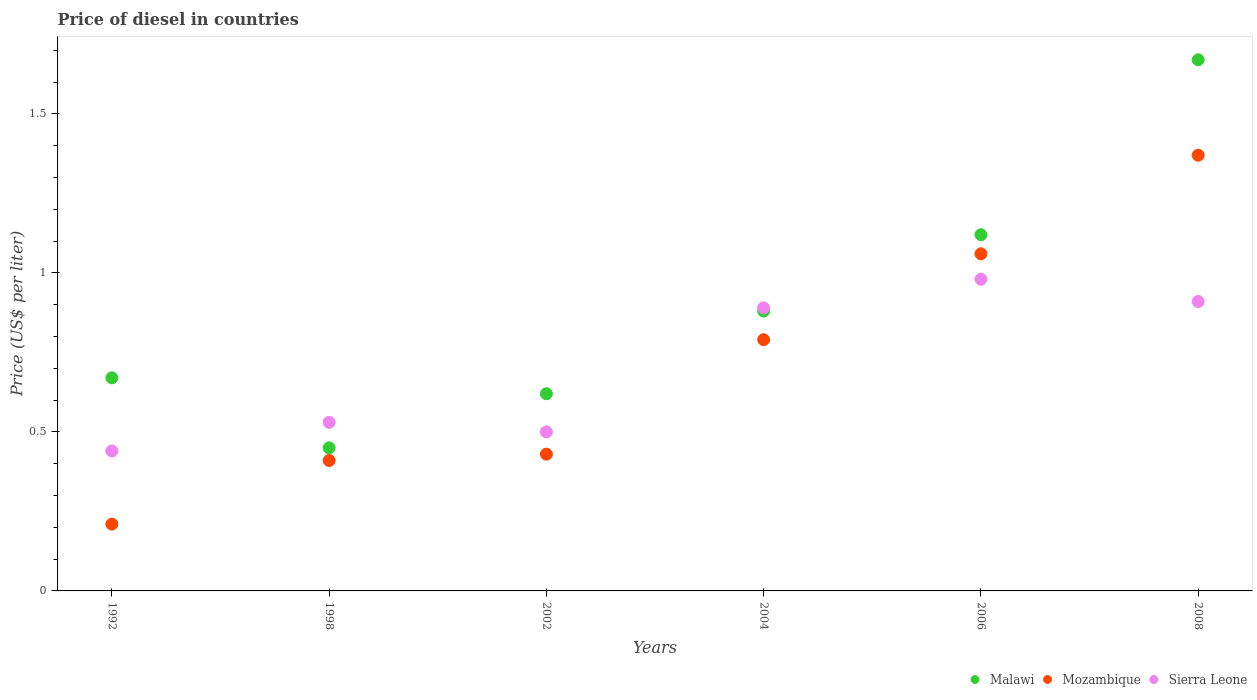How many different coloured dotlines are there?
Offer a very short reply. 3. What is the price of diesel in Mozambique in 2006?
Provide a short and direct response. 1.06. Across all years, what is the maximum price of diesel in Sierra Leone?
Give a very brief answer. 0.98. Across all years, what is the minimum price of diesel in Mozambique?
Give a very brief answer. 0.21. In which year was the price of diesel in Malawi maximum?
Offer a very short reply. 2008. In which year was the price of diesel in Malawi minimum?
Keep it short and to the point. 1998. What is the total price of diesel in Mozambique in the graph?
Your answer should be very brief. 4.27. What is the difference between the price of diesel in Sierra Leone in 1998 and that in 2008?
Provide a succinct answer. -0.38. What is the difference between the price of diesel in Mozambique in 2006 and the price of diesel in Sierra Leone in 1992?
Make the answer very short. 0.62. What is the average price of diesel in Sierra Leone per year?
Offer a terse response. 0.71. In the year 2008, what is the difference between the price of diesel in Mozambique and price of diesel in Sierra Leone?
Your answer should be very brief. 0.46. What is the ratio of the price of diesel in Malawi in 2004 to that in 2006?
Your answer should be very brief. 0.79. Is the difference between the price of diesel in Mozambique in 2006 and 2008 greater than the difference between the price of diesel in Sierra Leone in 2006 and 2008?
Provide a short and direct response. No. What is the difference between the highest and the second highest price of diesel in Sierra Leone?
Offer a very short reply. 0.07. What is the difference between the highest and the lowest price of diesel in Sierra Leone?
Provide a short and direct response. 0.54. Is the sum of the price of diesel in Mozambique in 1992 and 2004 greater than the maximum price of diesel in Malawi across all years?
Offer a terse response. No. Is it the case that in every year, the sum of the price of diesel in Sierra Leone and price of diesel in Mozambique  is greater than the price of diesel in Malawi?
Offer a terse response. No. Does the price of diesel in Malawi monotonically increase over the years?
Make the answer very short. No. Are the values on the major ticks of Y-axis written in scientific E-notation?
Provide a short and direct response. No. How many legend labels are there?
Ensure brevity in your answer.  3. How are the legend labels stacked?
Offer a terse response. Horizontal. What is the title of the graph?
Ensure brevity in your answer.  Price of diesel in countries. Does "European Union" appear as one of the legend labels in the graph?
Ensure brevity in your answer.  No. What is the label or title of the X-axis?
Give a very brief answer. Years. What is the label or title of the Y-axis?
Make the answer very short. Price (US$ per liter). What is the Price (US$ per liter) of Malawi in 1992?
Your response must be concise. 0.67. What is the Price (US$ per liter) in Mozambique in 1992?
Ensure brevity in your answer.  0.21. What is the Price (US$ per liter) of Sierra Leone in 1992?
Ensure brevity in your answer.  0.44. What is the Price (US$ per liter) in Malawi in 1998?
Give a very brief answer. 0.45. What is the Price (US$ per liter) in Mozambique in 1998?
Ensure brevity in your answer.  0.41. What is the Price (US$ per liter) of Sierra Leone in 1998?
Offer a terse response. 0.53. What is the Price (US$ per liter) of Malawi in 2002?
Your response must be concise. 0.62. What is the Price (US$ per liter) in Mozambique in 2002?
Your answer should be compact. 0.43. What is the Price (US$ per liter) in Sierra Leone in 2002?
Your response must be concise. 0.5. What is the Price (US$ per liter) of Malawi in 2004?
Your response must be concise. 0.88. What is the Price (US$ per liter) of Mozambique in 2004?
Ensure brevity in your answer.  0.79. What is the Price (US$ per liter) of Sierra Leone in 2004?
Give a very brief answer. 0.89. What is the Price (US$ per liter) in Malawi in 2006?
Offer a very short reply. 1.12. What is the Price (US$ per liter) in Mozambique in 2006?
Your answer should be compact. 1.06. What is the Price (US$ per liter) in Malawi in 2008?
Give a very brief answer. 1.67. What is the Price (US$ per liter) of Mozambique in 2008?
Give a very brief answer. 1.37. What is the Price (US$ per liter) in Sierra Leone in 2008?
Your answer should be very brief. 0.91. Across all years, what is the maximum Price (US$ per liter) in Malawi?
Ensure brevity in your answer.  1.67. Across all years, what is the maximum Price (US$ per liter) in Mozambique?
Offer a terse response. 1.37. Across all years, what is the maximum Price (US$ per liter) of Sierra Leone?
Your answer should be compact. 0.98. Across all years, what is the minimum Price (US$ per liter) in Malawi?
Offer a very short reply. 0.45. Across all years, what is the minimum Price (US$ per liter) in Mozambique?
Provide a short and direct response. 0.21. Across all years, what is the minimum Price (US$ per liter) of Sierra Leone?
Make the answer very short. 0.44. What is the total Price (US$ per liter) in Malawi in the graph?
Provide a succinct answer. 5.41. What is the total Price (US$ per liter) of Mozambique in the graph?
Provide a succinct answer. 4.27. What is the total Price (US$ per liter) in Sierra Leone in the graph?
Your answer should be compact. 4.25. What is the difference between the Price (US$ per liter) in Malawi in 1992 and that in 1998?
Your answer should be compact. 0.22. What is the difference between the Price (US$ per liter) in Sierra Leone in 1992 and that in 1998?
Provide a short and direct response. -0.09. What is the difference between the Price (US$ per liter) in Malawi in 1992 and that in 2002?
Give a very brief answer. 0.05. What is the difference between the Price (US$ per liter) in Mozambique in 1992 and that in 2002?
Provide a short and direct response. -0.22. What is the difference between the Price (US$ per liter) in Sierra Leone in 1992 and that in 2002?
Your answer should be very brief. -0.06. What is the difference between the Price (US$ per liter) in Malawi in 1992 and that in 2004?
Give a very brief answer. -0.21. What is the difference between the Price (US$ per liter) of Mozambique in 1992 and that in 2004?
Offer a very short reply. -0.58. What is the difference between the Price (US$ per liter) of Sierra Leone in 1992 and that in 2004?
Offer a terse response. -0.45. What is the difference between the Price (US$ per liter) of Malawi in 1992 and that in 2006?
Offer a terse response. -0.45. What is the difference between the Price (US$ per liter) of Mozambique in 1992 and that in 2006?
Give a very brief answer. -0.85. What is the difference between the Price (US$ per liter) in Sierra Leone in 1992 and that in 2006?
Your response must be concise. -0.54. What is the difference between the Price (US$ per liter) in Mozambique in 1992 and that in 2008?
Ensure brevity in your answer.  -1.16. What is the difference between the Price (US$ per liter) of Sierra Leone in 1992 and that in 2008?
Your answer should be very brief. -0.47. What is the difference between the Price (US$ per liter) of Malawi in 1998 and that in 2002?
Ensure brevity in your answer.  -0.17. What is the difference between the Price (US$ per liter) in Mozambique in 1998 and that in 2002?
Your answer should be very brief. -0.02. What is the difference between the Price (US$ per liter) in Malawi in 1998 and that in 2004?
Your response must be concise. -0.43. What is the difference between the Price (US$ per liter) in Mozambique in 1998 and that in 2004?
Make the answer very short. -0.38. What is the difference between the Price (US$ per liter) in Sierra Leone in 1998 and that in 2004?
Your response must be concise. -0.36. What is the difference between the Price (US$ per liter) of Malawi in 1998 and that in 2006?
Provide a succinct answer. -0.67. What is the difference between the Price (US$ per liter) of Mozambique in 1998 and that in 2006?
Ensure brevity in your answer.  -0.65. What is the difference between the Price (US$ per liter) of Sierra Leone in 1998 and that in 2006?
Provide a succinct answer. -0.45. What is the difference between the Price (US$ per liter) of Malawi in 1998 and that in 2008?
Offer a terse response. -1.22. What is the difference between the Price (US$ per liter) in Mozambique in 1998 and that in 2008?
Your answer should be very brief. -0.96. What is the difference between the Price (US$ per liter) in Sierra Leone in 1998 and that in 2008?
Provide a short and direct response. -0.38. What is the difference between the Price (US$ per liter) in Malawi in 2002 and that in 2004?
Your answer should be compact. -0.26. What is the difference between the Price (US$ per liter) of Mozambique in 2002 and that in 2004?
Ensure brevity in your answer.  -0.36. What is the difference between the Price (US$ per liter) of Sierra Leone in 2002 and that in 2004?
Offer a very short reply. -0.39. What is the difference between the Price (US$ per liter) in Mozambique in 2002 and that in 2006?
Give a very brief answer. -0.63. What is the difference between the Price (US$ per liter) of Sierra Leone in 2002 and that in 2006?
Offer a very short reply. -0.48. What is the difference between the Price (US$ per liter) of Malawi in 2002 and that in 2008?
Your answer should be very brief. -1.05. What is the difference between the Price (US$ per liter) in Mozambique in 2002 and that in 2008?
Give a very brief answer. -0.94. What is the difference between the Price (US$ per liter) of Sierra Leone in 2002 and that in 2008?
Give a very brief answer. -0.41. What is the difference between the Price (US$ per liter) of Malawi in 2004 and that in 2006?
Your response must be concise. -0.24. What is the difference between the Price (US$ per liter) in Mozambique in 2004 and that in 2006?
Keep it short and to the point. -0.27. What is the difference between the Price (US$ per liter) in Sierra Leone in 2004 and that in 2006?
Make the answer very short. -0.09. What is the difference between the Price (US$ per liter) in Malawi in 2004 and that in 2008?
Your answer should be compact. -0.79. What is the difference between the Price (US$ per liter) in Mozambique in 2004 and that in 2008?
Offer a terse response. -0.58. What is the difference between the Price (US$ per liter) of Sierra Leone in 2004 and that in 2008?
Offer a very short reply. -0.02. What is the difference between the Price (US$ per liter) of Malawi in 2006 and that in 2008?
Your response must be concise. -0.55. What is the difference between the Price (US$ per liter) in Mozambique in 2006 and that in 2008?
Your answer should be compact. -0.31. What is the difference between the Price (US$ per liter) of Sierra Leone in 2006 and that in 2008?
Provide a short and direct response. 0.07. What is the difference between the Price (US$ per liter) of Malawi in 1992 and the Price (US$ per liter) of Mozambique in 1998?
Make the answer very short. 0.26. What is the difference between the Price (US$ per liter) in Malawi in 1992 and the Price (US$ per liter) in Sierra Leone in 1998?
Your response must be concise. 0.14. What is the difference between the Price (US$ per liter) in Mozambique in 1992 and the Price (US$ per liter) in Sierra Leone in 1998?
Your response must be concise. -0.32. What is the difference between the Price (US$ per liter) of Malawi in 1992 and the Price (US$ per liter) of Mozambique in 2002?
Keep it short and to the point. 0.24. What is the difference between the Price (US$ per liter) of Malawi in 1992 and the Price (US$ per liter) of Sierra Leone in 2002?
Give a very brief answer. 0.17. What is the difference between the Price (US$ per liter) in Mozambique in 1992 and the Price (US$ per liter) in Sierra Leone in 2002?
Offer a terse response. -0.29. What is the difference between the Price (US$ per liter) of Malawi in 1992 and the Price (US$ per liter) of Mozambique in 2004?
Give a very brief answer. -0.12. What is the difference between the Price (US$ per liter) of Malawi in 1992 and the Price (US$ per liter) of Sierra Leone in 2004?
Offer a very short reply. -0.22. What is the difference between the Price (US$ per liter) of Mozambique in 1992 and the Price (US$ per liter) of Sierra Leone in 2004?
Provide a short and direct response. -0.68. What is the difference between the Price (US$ per liter) in Malawi in 1992 and the Price (US$ per liter) in Mozambique in 2006?
Keep it short and to the point. -0.39. What is the difference between the Price (US$ per liter) in Malawi in 1992 and the Price (US$ per liter) in Sierra Leone in 2006?
Keep it short and to the point. -0.31. What is the difference between the Price (US$ per liter) of Mozambique in 1992 and the Price (US$ per liter) of Sierra Leone in 2006?
Your answer should be very brief. -0.77. What is the difference between the Price (US$ per liter) in Malawi in 1992 and the Price (US$ per liter) in Sierra Leone in 2008?
Your answer should be compact. -0.24. What is the difference between the Price (US$ per liter) of Mozambique in 1992 and the Price (US$ per liter) of Sierra Leone in 2008?
Offer a very short reply. -0.7. What is the difference between the Price (US$ per liter) of Malawi in 1998 and the Price (US$ per liter) of Mozambique in 2002?
Offer a terse response. 0.02. What is the difference between the Price (US$ per liter) in Malawi in 1998 and the Price (US$ per liter) in Sierra Leone in 2002?
Offer a terse response. -0.05. What is the difference between the Price (US$ per liter) of Mozambique in 1998 and the Price (US$ per liter) of Sierra Leone in 2002?
Offer a very short reply. -0.09. What is the difference between the Price (US$ per liter) in Malawi in 1998 and the Price (US$ per liter) in Mozambique in 2004?
Keep it short and to the point. -0.34. What is the difference between the Price (US$ per liter) of Malawi in 1998 and the Price (US$ per liter) of Sierra Leone in 2004?
Provide a succinct answer. -0.44. What is the difference between the Price (US$ per liter) of Mozambique in 1998 and the Price (US$ per liter) of Sierra Leone in 2004?
Make the answer very short. -0.48. What is the difference between the Price (US$ per liter) of Malawi in 1998 and the Price (US$ per liter) of Mozambique in 2006?
Keep it short and to the point. -0.61. What is the difference between the Price (US$ per liter) of Malawi in 1998 and the Price (US$ per liter) of Sierra Leone in 2006?
Keep it short and to the point. -0.53. What is the difference between the Price (US$ per liter) of Mozambique in 1998 and the Price (US$ per liter) of Sierra Leone in 2006?
Provide a succinct answer. -0.57. What is the difference between the Price (US$ per liter) in Malawi in 1998 and the Price (US$ per liter) in Mozambique in 2008?
Your response must be concise. -0.92. What is the difference between the Price (US$ per liter) of Malawi in 1998 and the Price (US$ per liter) of Sierra Leone in 2008?
Ensure brevity in your answer.  -0.46. What is the difference between the Price (US$ per liter) of Mozambique in 1998 and the Price (US$ per liter) of Sierra Leone in 2008?
Keep it short and to the point. -0.5. What is the difference between the Price (US$ per liter) in Malawi in 2002 and the Price (US$ per liter) in Mozambique in 2004?
Provide a succinct answer. -0.17. What is the difference between the Price (US$ per liter) of Malawi in 2002 and the Price (US$ per liter) of Sierra Leone in 2004?
Give a very brief answer. -0.27. What is the difference between the Price (US$ per liter) in Mozambique in 2002 and the Price (US$ per liter) in Sierra Leone in 2004?
Your answer should be very brief. -0.46. What is the difference between the Price (US$ per liter) of Malawi in 2002 and the Price (US$ per liter) of Mozambique in 2006?
Ensure brevity in your answer.  -0.44. What is the difference between the Price (US$ per liter) of Malawi in 2002 and the Price (US$ per liter) of Sierra Leone in 2006?
Offer a terse response. -0.36. What is the difference between the Price (US$ per liter) in Mozambique in 2002 and the Price (US$ per liter) in Sierra Leone in 2006?
Keep it short and to the point. -0.55. What is the difference between the Price (US$ per liter) in Malawi in 2002 and the Price (US$ per liter) in Mozambique in 2008?
Provide a succinct answer. -0.75. What is the difference between the Price (US$ per liter) in Malawi in 2002 and the Price (US$ per liter) in Sierra Leone in 2008?
Your response must be concise. -0.29. What is the difference between the Price (US$ per liter) of Mozambique in 2002 and the Price (US$ per liter) of Sierra Leone in 2008?
Give a very brief answer. -0.48. What is the difference between the Price (US$ per liter) in Malawi in 2004 and the Price (US$ per liter) in Mozambique in 2006?
Your answer should be very brief. -0.18. What is the difference between the Price (US$ per liter) of Mozambique in 2004 and the Price (US$ per liter) of Sierra Leone in 2006?
Keep it short and to the point. -0.19. What is the difference between the Price (US$ per liter) in Malawi in 2004 and the Price (US$ per liter) in Mozambique in 2008?
Your answer should be very brief. -0.49. What is the difference between the Price (US$ per liter) of Malawi in 2004 and the Price (US$ per liter) of Sierra Leone in 2008?
Ensure brevity in your answer.  -0.03. What is the difference between the Price (US$ per liter) in Mozambique in 2004 and the Price (US$ per liter) in Sierra Leone in 2008?
Offer a terse response. -0.12. What is the difference between the Price (US$ per liter) of Malawi in 2006 and the Price (US$ per liter) of Mozambique in 2008?
Make the answer very short. -0.25. What is the difference between the Price (US$ per liter) in Malawi in 2006 and the Price (US$ per liter) in Sierra Leone in 2008?
Give a very brief answer. 0.21. What is the difference between the Price (US$ per liter) of Mozambique in 2006 and the Price (US$ per liter) of Sierra Leone in 2008?
Provide a succinct answer. 0.15. What is the average Price (US$ per liter) in Malawi per year?
Your answer should be very brief. 0.9. What is the average Price (US$ per liter) in Mozambique per year?
Your answer should be compact. 0.71. What is the average Price (US$ per liter) of Sierra Leone per year?
Offer a very short reply. 0.71. In the year 1992, what is the difference between the Price (US$ per liter) of Malawi and Price (US$ per liter) of Mozambique?
Give a very brief answer. 0.46. In the year 1992, what is the difference between the Price (US$ per liter) in Malawi and Price (US$ per liter) in Sierra Leone?
Offer a terse response. 0.23. In the year 1992, what is the difference between the Price (US$ per liter) in Mozambique and Price (US$ per liter) in Sierra Leone?
Offer a very short reply. -0.23. In the year 1998, what is the difference between the Price (US$ per liter) in Malawi and Price (US$ per liter) in Sierra Leone?
Provide a short and direct response. -0.08. In the year 1998, what is the difference between the Price (US$ per liter) in Mozambique and Price (US$ per liter) in Sierra Leone?
Make the answer very short. -0.12. In the year 2002, what is the difference between the Price (US$ per liter) of Malawi and Price (US$ per liter) of Mozambique?
Provide a short and direct response. 0.19. In the year 2002, what is the difference between the Price (US$ per liter) of Malawi and Price (US$ per liter) of Sierra Leone?
Your answer should be compact. 0.12. In the year 2002, what is the difference between the Price (US$ per liter) of Mozambique and Price (US$ per liter) of Sierra Leone?
Offer a terse response. -0.07. In the year 2004, what is the difference between the Price (US$ per liter) of Malawi and Price (US$ per liter) of Mozambique?
Offer a terse response. 0.09. In the year 2004, what is the difference between the Price (US$ per liter) of Malawi and Price (US$ per liter) of Sierra Leone?
Ensure brevity in your answer.  -0.01. In the year 2004, what is the difference between the Price (US$ per liter) in Mozambique and Price (US$ per liter) in Sierra Leone?
Your answer should be very brief. -0.1. In the year 2006, what is the difference between the Price (US$ per liter) in Malawi and Price (US$ per liter) in Sierra Leone?
Offer a very short reply. 0.14. In the year 2006, what is the difference between the Price (US$ per liter) in Mozambique and Price (US$ per liter) in Sierra Leone?
Give a very brief answer. 0.08. In the year 2008, what is the difference between the Price (US$ per liter) in Malawi and Price (US$ per liter) in Mozambique?
Your response must be concise. 0.3. In the year 2008, what is the difference between the Price (US$ per liter) of Malawi and Price (US$ per liter) of Sierra Leone?
Make the answer very short. 0.76. In the year 2008, what is the difference between the Price (US$ per liter) of Mozambique and Price (US$ per liter) of Sierra Leone?
Keep it short and to the point. 0.46. What is the ratio of the Price (US$ per liter) of Malawi in 1992 to that in 1998?
Ensure brevity in your answer.  1.49. What is the ratio of the Price (US$ per liter) of Mozambique in 1992 to that in 1998?
Offer a very short reply. 0.51. What is the ratio of the Price (US$ per liter) of Sierra Leone in 1992 to that in 1998?
Provide a short and direct response. 0.83. What is the ratio of the Price (US$ per liter) of Malawi in 1992 to that in 2002?
Provide a succinct answer. 1.08. What is the ratio of the Price (US$ per liter) of Mozambique in 1992 to that in 2002?
Your answer should be compact. 0.49. What is the ratio of the Price (US$ per liter) in Malawi in 1992 to that in 2004?
Your answer should be very brief. 0.76. What is the ratio of the Price (US$ per liter) of Mozambique in 1992 to that in 2004?
Give a very brief answer. 0.27. What is the ratio of the Price (US$ per liter) of Sierra Leone in 1992 to that in 2004?
Offer a very short reply. 0.49. What is the ratio of the Price (US$ per liter) of Malawi in 1992 to that in 2006?
Make the answer very short. 0.6. What is the ratio of the Price (US$ per liter) in Mozambique in 1992 to that in 2006?
Offer a very short reply. 0.2. What is the ratio of the Price (US$ per liter) in Sierra Leone in 1992 to that in 2006?
Your answer should be compact. 0.45. What is the ratio of the Price (US$ per liter) in Malawi in 1992 to that in 2008?
Provide a short and direct response. 0.4. What is the ratio of the Price (US$ per liter) in Mozambique in 1992 to that in 2008?
Ensure brevity in your answer.  0.15. What is the ratio of the Price (US$ per liter) of Sierra Leone in 1992 to that in 2008?
Provide a short and direct response. 0.48. What is the ratio of the Price (US$ per liter) in Malawi in 1998 to that in 2002?
Offer a terse response. 0.73. What is the ratio of the Price (US$ per liter) in Mozambique in 1998 to that in 2002?
Offer a terse response. 0.95. What is the ratio of the Price (US$ per liter) in Sierra Leone in 1998 to that in 2002?
Your response must be concise. 1.06. What is the ratio of the Price (US$ per liter) of Malawi in 1998 to that in 2004?
Provide a short and direct response. 0.51. What is the ratio of the Price (US$ per liter) in Mozambique in 1998 to that in 2004?
Offer a terse response. 0.52. What is the ratio of the Price (US$ per liter) of Sierra Leone in 1998 to that in 2004?
Keep it short and to the point. 0.6. What is the ratio of the Price (US$ per liter) in Malawi in 1998 to that in 2006?
Offer a terse response. 0.4. What is the ratio of the Price (US$ per liter) of Mozambique in 1998 to that in 2006?
Provide a short and direct response. 0.39. What is the ratio of the Price (US$ per liter) of Sierra Leone in 1998 to that in 2006?
Offer a very short reply. 0.54. What is the ratio of the Price (US$ per liter) in Malawi in 1998 to that in 2008?
Offer a very short reply. 0.27. What is the ratio of the Price (US$ per liter) of Mozambique in 1998 to that in 2008?
Ensure brevity in your answer.  0.3. What is the ratio of the Price (US$ per liter) in Sierra Leone in 1998 to that in 2008?
Provide a short and direct response. 0.58. What is the ratio of the Price (US$ per liter) of Malawi in 2002 to that in 2004?
Your response must be concise. 0.7. What is the ratio of the Price (US$ per liter) of Mozambique in 2002 to that in 2004?
Offer a very short reply. 0.54. What is the ratio of the Price (US$ per liter) in Sierra Leone in 2002 to that in 2004?
Make the answer very short. 0.56. What is the ratio of the Price (US$ per liter) of Malawi in 2002 to that in 2006?
Ensure brevity in your answer.  0.55. What is the ratio of the Price (US$ per liter) in Mozambique in 2002 to that in 2006?
Keep it short and to the point. 0.41. What is the ratio of the Price (US$ per liter) in Sierra Leone in 2002 to that in 2006?
Give a very brief answer. 0.51. What is the ratio of the Price (US$ per liter) in Malawi in 2002 to that in 2008?
Keep it short and to the point. 0.37. What is the ratio of the Price (US$ per liter) of Mozambique in 2002 to that in 2008?
Offer a very short reply. 0.31. What is the ratio of the Price (US$ per liter) of Sierra Leone in 2002 to that in 2008?
Your response must be concise. 0.55. What is the ratio of the Price (US$ per liter) of Malawi in 2004 to that in 2006?
Your answer should be very brief. 0.79. What is the ratio of the Price (US$ per liter) of Mozambique in 2004 to that in 2006?
Keep it short and to the point. 0.75. What is the ratio of the Price (US$ per liter) of Sierra Leone in 2004 to that in 2006?
Provide a short and direct response. 0.91. What is the ratio of the Price (US$ per liter) in Malawi in 2004 to that in 2008?
Offer a terse response. 0.53. What is the ratio of the Price (US$ per liter) in Mozambique in 2004 to that in 2008?
Offer a terse response. 0.58. What is the ratio of the Price (US$ per liter) in Sierra Leone in 2004 to that in 2008?
Your response must be concise. 0.98. What is the ratio of the Price (US$ per liter) of Malawi in 2006 to that in 2008?
Your response must be concise. 0.67. What is the ratio of the Price (US$ per liter) in Mozambique in 2006 to that in 2008?
Give a very brief answer. 0.77. What is the ratio of the Price (US$ per liter) in Sierra Leone in 2006 to that in 2008?
Your answer should be very brief. 1.08. What is the difference between the highest and the second highest Price (US$ per liter) of Malawi?
Your response must be concise. 0.55. What is the difference between the highest and the second highest Price (US$ per liter) of Mozambique?
Keep it short and to the point. 0.31. What is the difference between the highest and the second highest Price (US$ per liter) in Sierra Leone?
Your answer should be compact. 0.07. What is the difference between the highest and the lowest Price (US$ per liter) of Malawi?
Your answer should be compact. 1.22. What is the difference between the highest and the lowest Price (US$ per liter) of Mozambique?
Your answer should be very brief. 1.16. What is the difference between the highest and the lowest Price (US$ per liter) in Sierra Leone?
Make the answer very short. 0.54. 